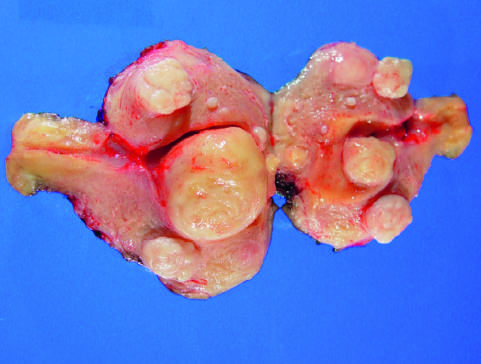what is opened to show multiple submucosal, myometrial, and subserosal gray-white tumors, each with a characteristic whorled appearance on cut section?
Answer the question using a single word or phrase. The uterus 